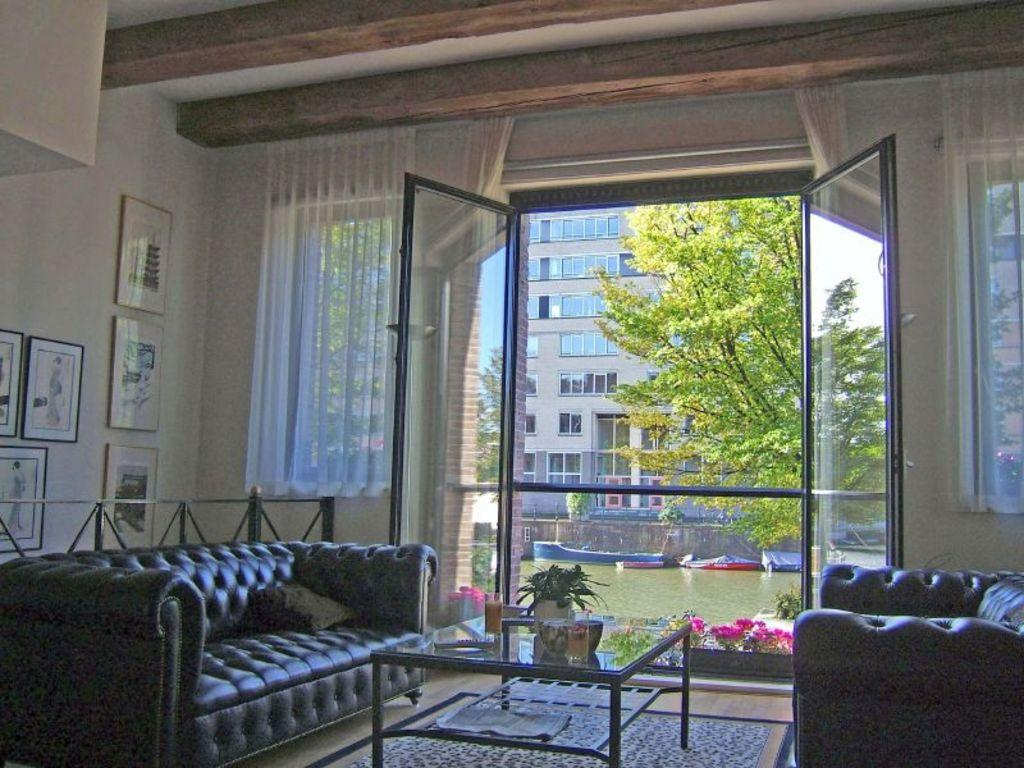What type of furniture can be seen in the image? There is a sofa in the image. What other piece of furniture is present in the image? There is a table in the image. What is the background of the image made up of? There is a wall in the image, and in the background, there are trees and a building. Are there any decorative items in the image? Yes, there are frames in the image. Can you describe the presence of water in the image? There is water in the image. What type of window treatment is visible in the image? There is a curtain in the image. Is there an entrance or exit in the image? Yes, there is a door in the image. What surface is the furniture placed on? There is a floor in the image. What type of fowl can be seen swimming in the water in the image? There are no fowl present in the image, and the water does not show any swimming creatures. Can you describe the jellyfish floating near the door in the image? There are no jellyfish present in the image, as it is an indoor setting with no aquatic life. 